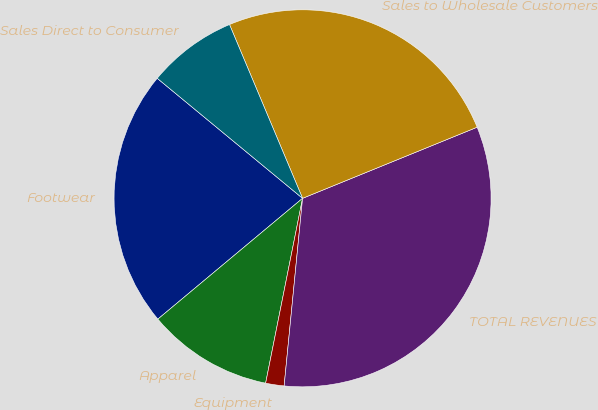Convert chart. <chart><loc_0><loc_0><loc_500><loc_500><pie_chart><fcel>Footwear<fcel>Apparel<fcel>Equipment<fcel>TOTAL REVENUES<fcel>Sales to Wholesale Customers<fcel>Sales Direct to Consumer<nl><fcel>22.06%<fcel>10.79%<fcel>1.58%<fcel>32.72%<fcel>25.18%<fcel>7.68%<nl></chart> 